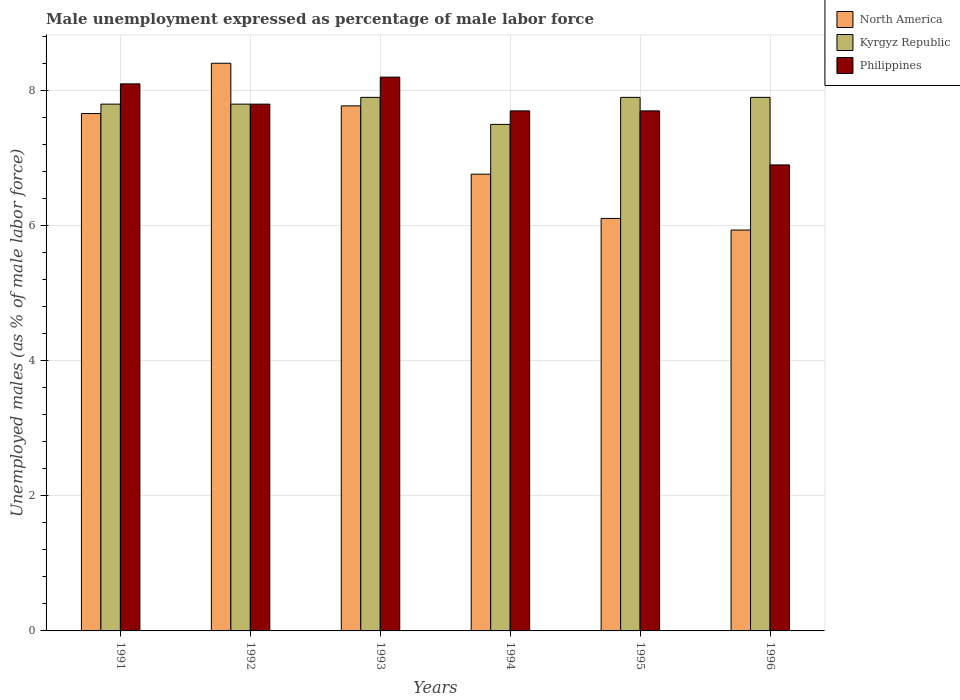Are the number of bars per tick equal to the number of legend labels?
Keep it short and to the point. Yes. How many bars are there on the 6th tick from the left?
Offer a terse response. 3. In how many cases, is the number of bars for a given year not equal to the number of legend labels?
Ensure brevity in your answer.  0. What is the unemployment in males in in Kyrgyz Republic in 1994?
Provide a short and direct response. 7.5. Across all years, what is the maximum unemployment in males in in Philippines?
Provide a succinct answer. 8.2. Across all years, what is the minimum unemployment in males in in Philippines?
Provide a short and direct response. 6.9. In which year was the unemployment in males in in Philippines maximum?
Your response must be concise. 1993. What is the total unemployment in males in in Kyrgyz Republic in the graph?
Provide a succinct answer. 46.8. What is the difference between the unemployment in males in in Philippines in 1993 and that in 1996?
Your answer should be very brief. 1.3. What is the difference between the unemployment in males in in Philippines in 1996 and the unemployment in males in in North America in 1995?
Ensure brevity in your answer.  0.79. What is the average unemployment in males in in Philippines per year?
Your answer should be very brief. 7.73. In the year 1996, what is the difference between the unemployment in males in in Kyrgyz Republic and unemployment in males in in North America?
Provide a short and direct response. 1.96. In how many years, is the unemployment in males in in North America greater than 2 %?
Your answer should be compact. 6. What is the ratio of the unemployment in males in in North America in 1995 to that in 1996?
Provide a succinct answer. 1.03. Is the unemployment in males in in North America in 1995 less than that in 1996?
Your response must be concise. No. Is the difference between the unemployment in males in in Kyrgyz Republic in 1995 and 1996 greater than the difference between the unemployment in males in in North America in 1995 and 1996?
Your response must be concise. No. What is the difference between the highest and the second highest unemployment in males in in Philippines?
Offer a very short reply. 0.1. What is the difference between the highest and the lowest unemployment in males in in Philippines?
Ensure brevity in your answer.  1.3. In how many years, is the unemployment in males in in Philippines greater than the average unemployment in males in in Philippines taken over all years?
Offer a very short reply. 3. Is the sum of the unemployment in males in in Kyrgyz Republic in 1991 and 1995 greater than the maximum unemployment in males in in North America across all years?
Make the answer very short. Yes. What does the 2nd bar from the left in 1993 represents?
Keep it short and to the point. Kyrgyz Republic. What does the 2nd bar from the right in 1995 represents?
Offer a terse response. Kyrgyz Republic. How many years are there in the graph?
Make the answer very short. 6. What is the difference between two consecutive major ticks on the Y-axis?
Offer a terse response. 2. Are the values on the major ticks of Y-axis written in scientific E-notation?
Your answer should be compact. No. Does the graph contain any zero values?
Give a very brief answer. No. Does the graph contain grids?
Offer a terse response. Yes. Where does the legend appear in the graph?
Your answer should be very brief. Top right. What is the title of the graph?
Offer a very short reply. Male unemployment expressed as percentage of male labor force. What is the label or title of the Y-axis?
Your response must be concise. Unemployed males (as % of male labor force). What is the Unemployed males (as % of male labor force) in North America in 1991?
Make the answer very short. 7.66. What is the Unemployed males (as % of male labor force) of Kyrgyz Republic in 1991?
Keep it short and to the point. 7.8. What is the Unemployed males (as % of male labor force) in Philippines in 1991?
Ensure brevity in your answer.  8.1. What is the Unemployed males (as % of male labor force) of North America in 1992?
Keep it short and to the point. 8.41. What is the Unemployed males (as % of male labor force) of Kyrgyz Republic in 1992?
Make the answer very short. 7.8. What is the Unemployed males (as % of male labor force) in Philippines in 1992?
Keep it short and to the point. 7.8. What is the Unemployed males (as % of male labor force) of North America in 1993?
Keep it short and to the point. 7.77. What is the Unemployed males (as % of male labor force) in Kyrgyz Republic in 1993?
Keep it short and to the point. 7.9. What is the Unemployed males (as % of male labor force) in Philippines in 1993?
Ensure brevity in your answer.  8.2. What is the Unemployed males (as % of male labor force) of North America in 1994?
Keep it short and to the point. 6.76. What is the Unemployed males (as % of male labor force) in Philippines in 1994?
Ensure brevity in your answer.  7.7. What is the Unemployed males (as % of male labor force) of North America in 1995?
Make the answer very short. 6.11. What is the Unemployed males (as % of male labor force) in Kyrgyz Republic in 1995?
Provide a succinct answer. 7.9. What is the Unemployed males (as % of male labor force) of Philippines in 1995?
Provide a short and direct response. 7.7. What is the Unemployed males (as % of male labor force) of North America in 1996?
Give a very brief answer. 5.94. What is the Unemployed males (as % of male labor force) of Kyrgyz Republic in 1996?
Provide a short and direct response. 7.9. What is the Unemployed males (as % of male labor force) of Philippines in 1996?
Your answer should be compact. 6.9. Across all years, what is the maximum Unemployed males (as % of male labor force) of North America?
Offer a terse response. 8.41. Across all years, what is the maximum Unemployed males (as % of male labor force) in Kyrgyz Republic?
Ensure brevity in your answer.  7.9. Across all years, what is the maximum Unemployed males (as % of male labor force) in Philippines?
Provide a succinct answer. 8.2. Across all years, what is the minimum Unemployed males (as % of male labor force) of North America?
Provide a short and direct response. 5.94. Across all years, what is the minimum Unemployed males (as % of male labor force) in Kyrgyz Republic?
Keep it short and to the point. 7.5. Across all years, what is the minimum Unemployed males (as % of male labor force) of Philippines?
Your answer should be very brief. 6.9. What is the total Unemployed males (as % of male labor force) of North America in the graph?
Provide a short and direct response. 42.65. What is the total Unemployed males (as % of male labor force) of Kyrgyz Republic in the graph?
Make the answer very short. 46.8. What is the total Unemployed males (as % of male labor force) in Philippines in the graph?
Keep it short and to the point. 46.4. What is the difference between the Unemployed males (as % of male labor force) of North America in 1991 and that in 1992?
Provide a short and direct response. -0.74. What is the difference between the Unemployed males (as % of male labor force) in Kyrgyz Republic in 1991 and that in 1992?
Your response must be concise. 0. What is the difference between the Unemployed males (as % of male labor force) in North America in 1991 and that in 1993?
Keep it short and to the point. -0.11. What is the difference between the Unemployed males (as % of male labor force) in North America in 1991 and that in 1994?
Provide a short and direct response. 0.9. What is the difference between the Unemployed males (as % of male labor force) of North America in 1991 and that in 1995?
Your answer should be very brief. 1.55. What is the difference between the Unemployed males (as % of male labor force) in Philippines in 1991 and that in 1995?
Your answer should be very brief. 0.4. What is the difference between the Unemployed males (as % of male labor force) of North America in 1991 and that in 1996?
Offer a very short reply. 1.72. What is the difference between the Unemployed males (as % of male labor force) in Kyrgyz Republic in 1991 and that in 1996?
Your answer should be compact. -0.1. What is the difference between the Unemployed males (as % of male labor force) in Philippines in 1991 and that in 1996?
Offer a very short reply. 1.2. What is the difference between the Unemployed males (as % of male labor force) of North America in 1992 and that in 1993?
Provide a short and direct response. 0.63. What is the difference between the Unemployed males (as % of male labor force) of Philippines in 1992 and that in 1993?
Ensure brevity in your answer.  -0.4. What is the difference between the Unemployed males (as % of male labor force) in North America in 1992 and that in 1994?
Your answer should be very brief. 1.64. What is the difference between the Unemployed males (as % of male labor force) in North America in 1992 and that in 1995?
Ensure brevity in your answer.  2.3. What is the difference between the Unemployed males (as % of male labor force) of North America in 1992 and that in 1996?
Your answer should be very brief. 2.47. What is the difference between the Unemployed males (as % of male labor force) of Kyrgyz Republic in 1992 and that in 1996?
Make the answer very short. -0.1. What is the difference between the Unemployed males (as % of male labor force) in Philippines in 1992 and that in 1996?
Your answer should be very brief. 0.9. What is the difference between the Unemployed males (as % of male labor force) in North America in 1993 and that in 1994?
Offer a terse response. 1.01. What is the difference between the Unemployed males (as % of male labor force) of North America in 1993 and that in 1995?
Offer a terse response. 1.67. What is the difference between the Unemployed males (as % of male labor force) in Philippines in 1993 and that in 1995?
Ensure brevity in your answer.  0.5. What is the difference between the Unemployed males (as % of male labor force) of North America in 1993 and that in 1996?
Your response must be concise. 1.84. What is the difference between the Unemployed males (as % of male labor force) of Kyrgyz Republic in 1993 and that in 1996?
Your answer should be very brief. 0. What is the difference between the Unemployed males (as % of male labor force) in North America in 1994 and that in 1995?
Offer a terse response. 0.66. What is the difference between the Unemployed males (as % of male labor force) of Kyrgyz Republic in 1994 and that in 1995?
Your answer should be very brief. -0.4. What is the difference between the Unemployed males (as % of male labor force) of North America in 1994 and that in 1996?
Give a very brief answer. 0.83. What is the difference between the Unemployed males (as % of male labor force) in Kyrgyz Republic in 1994 and that in 1996?
Provide a short and direct response. -0.4. What is the difference between the Unemployed males (as % of male labor force) in Philippines in 1994 and that in 1996?
Ensure brevity in your answer.  0.8. What is the difference between the Unemployed males (as % of male labor force) in North America in 1995 and that in 1996?
Ensure brevity in your answer.  0.17. What is the difference between the Unemployed males (as % of male labor force) of North America in 1991 and the Unemployed males (as % of male labor force) of Kyrgyz Republic in 1992?
Your response must be concise. -0.14. What is the difference between the Unemployed males (as % of male labor force) of North America in 1991 and the Unemployed males (as % of male labor force) of Philippines in 1992?
Provide a short and direct response. -0.14. What is the difference between the Unemployed males (as % of male labor force) of North America in 1991 and the Unemployed males (as % of male labor force) of Kyrgyz Republic in 1993?
Provide a short and direct response. -0.24. What is the difference between the Unemployed males (as % of male labor force) in North America in 1991 and the Unemployed males (as % of male labor force) in Philippines in 1993?
Your answer should be compact. -0.54. What is the difference between the Unemployed males (as % of male labor force) of North America in 1991 and the Unemployed males (as % of male labor force) of Kyrgyz Republic in 1994?
Your answer should be compact. 0.16. What is the difference between the Unemployed males (as % of male labor force) in North America in 1991 and the Unemployed males (as % of male labor force) in Philippines in 1994?
Offer a very short reply. -0.04. What is the difference between the Unemployed males (as % of male labor force) in North America in 1991 and the Unemployed males (as % of male labor force) in Kyrgyz Republic in 1995?
Ensure brevity in your answer.  -0.24. What is the difference between the Unemployed males (as % of male labor force) in North America in 1991 and the Unemployed males (as % of male labor force) in Philippines in 1995?
Give a very brief answer. -0.04. What is the difference between the Unemployed males (as % of male labor force) of North America in 1991 and the Unemployed males (as % of male labor force) of Kyrgyz Republic in 1996?
Offer a very short reply. -0.24. What is the difference between the Unemployed males (as % of male labor force) in North America in 1991 and the Unemployed males (as % of male labor force) in Philippines in 1996?
Provide a short and direct response. 0.76. What is the difference between the Unemployed males (as % of male labor force) in North America in 1992 and the Unemployed males (as % of male labor force) in Kyrgyz Republic in 1993?
Provide a short and direct response. 0.51. What is the difference between the Unemployed males (as % of male labor force) of North America in 1992 and the Unemployed males (as % of male labor force) of Philippines in 1993?
Keep it short and to the point. 0.21. What is the difference between the Unemployed males (as % of male labor force) in Kyrgyz Republic in 1992 and the Unemployed males (as % of male labor force) in Philippines in 1993?
Make the answer very short. -0.4. What is the difference between the Unemployed males (as % of male labor force) of North America in 1992 and the Unemployed males (as % of male labor force) of Kyrgyz Republic in 1994?
Your answer should be very brief. 0.91. What is the difference between the Unemployed males (as % of male labor force) in North America in 1992 and the Unemployed males (as % of male labor force) in Philippines in 1994?
Provide a short and direct response. 0.71. What is the difference between the Unemployed males (as % of male labor force) of North America in 1992 and the Unemployed males (as % of male labor force) of Kyrgyz Republic in 1995?
Your answer should be compact. 0.51. What is the difference between the Unemployed males (as % of male labor force) in North America in 1992 and the Unemployed males (as % of male labor force) in Philippines in 1995?
Your answer should be compact. 0.71. What is the difference between the Unemployed males (as % of male labor force) in Kyrgyz Republic in 1992 and the Unemployed males (as % of male labor force) in Philippines in 1995?
Your answer should be very brief. 0.1. What is the difference between the Unemployed males (as % of male labor force) in North America in 1992 and the Unemployed males (as % of male labor force) in Kyrgyz Republic in 1996?
Your answer should be compact. 0.51. What is the difference between the Unemployed males (as % of male labor force) in North America in 1992 and the Unemployed males (as % of male labor force) in Philippines in 1996?
Your response must be concise. 1.51. What is the difference between the Unemployed males (as % of male labor force) of North America in 1993 and the Unemployed males (as % of male labor force) of Kyrgyz Republic in 1994?
Your answer should be very brief. 0.27. What is the difference between the Unemployed males (as % of male labor force) of North America in 1993 and the Unemployed males (as % of male labor force) of Philippines in 1994?
Your answer should be very brief. 0.07. What is the difference between the Unemployed males (as % of male labor force) in Kyrgyz Republic in 1993 and the Unemployed males (as % of male labor force) in Philippines in 1994?
Provide a short and direct response. 0.2. What is the difference between the Unemployed males (as % of male labor force) in North America in 1993 and the Unemployed males (as % of male labor force) in Kyrgyz Republic in 1995?
Your answer should be very brief. -0.13. What is the difference between the Unemployed males (as % of male labor force) in North America in 1993 and the Unemployed males (as % of male labor force) in Philippines in 1995?
Give a very brief answer. 0.07. What is the difference between the Unemployed males (as % of male labor force) in Kyrgyz Republic in 1993 and the Unemployed males (as % of male labor force) in Philippines in 1995?
Ensure brevity in your answer.  0.2. What is the difference between the Unemployed males (as % of male labor force) of North America in 1993 and the Unemployed males (as % of male labor force) of Kyrgyz Republic in 1996?
Your answer should be compact. -0.13. What is the difference between the Unemployed males (as % of male labor force) in North America in 1993 and the Unemployed males (as % of male labor force) in Philippines in 1996?
Your answer should be very brief. 0.87. What is the difference between the Unemployed males (as % of male labor force) in North America in 1994 and the Unemployed males (as % of male labor force) in Kyrgyz Republic in 1995?
Offer a very short reply. -1.14. What is the difference between the Unemployed males (as % of male labor force) in North America in 1994 and the Unemployed males (as % of male labor force) in Philippines in 1995?
Your answer should be compact. -0.94. What is the difference between the Unemployed males (as % of male labor force) in Kyrgyz Republic in 1994 and the Unemployed males (as % of male labor force) in Philippines in 1995?
Your response must be concise. -0.2. What is the difference between the Unemployed males (as % of male labor force) in North America in 1994 and the Unemployed males (as % of male labor force) in Kyrgyz Republic in 1996?
Your response must be concise. -1.14. What is the difference between the Unemployed males (as % of male labor force) in North America in 1994 and the Unemployed males (as % of male labor force) in Philippines in 1996?
Provide a short and direct response. -0.14. What is the difference between the Unemployed males (as % of male labor force) in North America in 1995 and the Unemployed males (as % of male labor force) in Kyrgyz Republic in 1996?
Make the answer very short. -1.79. What is the difference between the Unemployed males (as % of male labor force) of North America in 1995 and the Unemployed males (as % of male labor force) of Philippines in 1996?
Give a very brief answer. -0.79. What is the difference between the Unemployed males (as % of male labor force) of Kyrgyz Republic in 1995 and the Unemployed males (as % of male labor force) of Philippines in 1996?
Provide a succinct answer. 1. What is the average Unemployed males (as % of male labor force) in North America per year?
Offer a terse response. 7.11. What is the average Unemployed males (as % of male labor force) in Philippines per year?
Make the answer very short. 7.73. In the year 1991, what is the difference between the Unemployed males (as % of male labor force) of North America and Unemployed males (as % of male labor force) of Kyrgyz Republic?
Offer a terse response. -0.14. In the year 1991, what is the difference between the Unemployed males (as % of male labor force) of North America and Unemployed males (as % of male labor force) of Philippines?
Ensure brevity in your answer.  -0.44. In the year 1991, what is the difference between the Unemployed males (as % of male labor force) of Kyrgyz Republic and Unemployed males (as % of male labor force) of Philippines?
Provide a short and direct response. -0.3. In the year 1992, what is the difference between the Unemployed males (as % of male labor force) of North America and Unemployed males (as % of male labor force) of Kyrgyz Republic?
Offer a very short reply. 0.61. In the year 1992, what is the difference between the Unemployed males (as % of male labor force) in North America and Unemployed males (as % of male labor force) in Philippines?
Give a very brief answer. 0.61. In the year 1992, what is the difference between the Unemployed males (as % of male labor force) in Kyrgyz Republic and Unemployed males (as % of male labor force) in Philippines?
Your response must be concise. 0. In the year 1993, what is the difference between the Unemployed males (as % of male labor force) in North America and Unemployed males (as % of male labor force) in Kyrgyz Republic?
Keep it short and to the point. -0.13. In the year 1993, what is the difference between the Unemployed males (as % of male labor force) in North America and Unemployed males (as % of male labor force) in Philippines?
Give a very brief answer. -0.43. In the year 1994, what is the difference between the Unemployed males (as % of male labor force) in North America and Unemployed males (as % of male labor force) in Kyrgyz Republic?
Provide a succinct answer. -0.74. In the year 1994, what is the difference between the Unemployed males (as % of male labor force) in North America and Unemployed males (as % of male labor force) in Philippines?
Make the answer very short. -0.94. In the year 1995, what is the difference between the Unemployed males (as % of male labor force) of North America and Unemployed males (as % of male labor force) of Kyrgyz Republic?
Your answer should be very brief. -1.79. In the year 1995, what is the difference between the Unemployed males (as % of male labor force) of North America and Unemployed males (as % of male labor force) of Philippines?
Offer a very short reply. -1.59. In the year 1996, what is the difference between the Unemployed males (as % of male labor force) of North America and Unemployed males (as % of male labor force) of Kyrgyz Republic?
Provide a succinct answer. -1.96. In the year 1996, what is the difference between the Unemployed males (as % of male labor force) in North America and Unemployed males (as % of male labor force) in Philippines?
Provide a succinct answer. -0.96. In the year 1996, what is the difference between the Unemployed males (as % of male labor force) in Kyrgyz Republic and Unemployed males (as % of male labor force) in Philippines?
Offer a very short reply. 1. What is the ratio of the Unemployed males (as % of male labor force) in North America in 1991 to that in 1992?
Your response must be concise. 0.91. What is the ratio of the Unemployed males (as % of male labor force) of Philippines in 1991 to that in 1992?
Offer a very short reply. 1.04. What is the ratio of the Unemployed males (as % of male labor force) in North America in 1991 to that in 1993?
Ensure brevity in your answer.  0.99. What is the ratio of the Unemployed males (as % of male labor force) in Kyrgyz Republic in 1991 to that in 1993?
Your answer should be compact. 0.99. What is the ratio of the Unemployed males (as % of male labor force) in Philippines in 1991 to that in 1993?
Your answer should be compact. 0.99. What is the ratio of the Unemployed males (as % of male labor force) in North America in 1991 to that in 1994?
Your answer should be compact. 1.13. What is the ratio of the Unemployed males (as % of male labor force) of Philippines in 1991 to that in 1994?
Ensure brevity in your answer.  1.05. What is the ratio of the Unemployed males (as % of male labor force) of North America in 1991 to that in 1995?
Make the answer very short. 1.25. What is the ratio of the Unemployed males (as % of male labor force) in Kyrgyz Republic in 1991 to that in 1995?
Ensure brevity in your answer.  0.99. What is the ratio of the Unemployed males (as % of male labor force) in Philippines in 1991 to that in 1995?
Provide a succinct answer. 1.05. What is the ratio of the Unemployed males (as % of male labor force) of North America in 1991 to that in 1996?
Provide a short and direct response. 1.29. What is the ratio of the Unemployed males (as % of male labor force) in Kyrgyz Republic in 1991 to that in 1996?
Provide a succinct answer. 0.99. What is the ratio of the Unemployed males (as % of male labor force) in Philippines in 1991 to that in 1996?
Keep it short and to the point. 1.17. What is the ratio of the Unemployed males (as % of male labor force) of North America in 1992 to that in 1993?
Offer a very short reply. 1.08. What is the ratio of the Unemployed males (as % of male labor force) in Kyrgyz Republic in 1992 to that in 1993?
Your response must be concise. 0.99. What is the ratio of the Unemployed males (as % of male labor force) in Philippines in 1992 to that in 1993?
Ensure brevity in your answer.  0.95. What is the ratio of the Unemployed males (as % of male labor force) in North America in 1992 to that in 1994?
Make the answer very short. 1.24. What is the ratio of the Unemployed males (as % of male labor force) in North America in 1992 to that in 1995?
Offer a very short reply. 1.38. What is the ratio of the Unemployed males (as % of male labor force) in Kyrgyz Republic in 1992 to that in 1995?
Provide a short and direct response. 0.99. What is the ratio of the Unemployed males (as % of male labor force) in North America in 1992 to that in 1996?
Your answer should be compact. 1.42. What is the ratio of the Unemployed males (as % of male labor force) of Kyrgyz Republic in 1992 to that in 1996?
Ensure brevity in your answer.  0.99. What is the ratio of the Unemployed males (as % of male labor force) of Philippines in 1992 to that in 1996?
Make the answer very short. 1.13. What is the ratio of the Unemployed males (as % of male labor force) in North America in 1993 to that in 1994?
Provide a succinct answer. 1.15. What is the ratio of the Unemployed males (as % of male labor force) in Kyrgyz Republic in 1993 to that in 1994?
Provide a short and direct response. 1.05. What is the ratio of the Unemployed males (as % of male labor force) of Philippines in 1993 to that in 1994?
Give a very brief answer. 1.06. What is the ratio of the Unemployed males (as % of male labor force) of North America in 1993 to that in 1995?
Your answer should be compact. 1.27. What is the ratio of the Unemployed males (as % of male labor force) of Philippines in 1993 to that in 1995?
Your response must be concise. 1.06. What is the ratio of the Unemployed males (as % of male labor force) of North America in 1993 to that in 1996?
Keep it short and to the point. 1.31. What is the ratio of the Unemployed males (as % of male labor force) in Kyrgyz Republic in 1993 to that in 1996?
Your answer should be very brief. 1. What is the ratio of the Unemployed males (as % of male labor force) of Philippines in 1993 to that in 1996?
Provide a short and direct response. 1.19. What is the ratio of the Unemployed males (as % of male labor force) in North America in 1994 to that in 1995?
Your response must be concise. 1.11. What is the ratio of the Unemployed males (as % of male labor force) in Kyrgyz Republic in 1994 to that in 1995?
Provide a succinct answer. 0.95. What is the ratio of the Unemployed males (as % of male labor force) in North America in 1994 to that in 1996?
Your response must be concise. 1.14. What is the ratio of the Unemployed males (as % of male labor force) in Kyrgyz Republic in 1994 to that in 1996?
Provide a short and direct response. 0.95. What is the ratio of the Unemployed males (as % of male labor force) in Philippines in 1994 to that in 1996?
Your response must be concise. 1.12. What is the ratio of the Unemployed males (as % of male labor force) of North America in 1995 to that in 1996?
Ensure brevity in your answer.  1.03. What is the ratio of the Unemployed males (as % of male labor force) of Philippines in 1995 to that in 1996?
Make the answer very short. 1.12. What is the difference between the highest and the second highest Unemployed males (as % of male labor force) in North America?
Keep it short and to the point. 0.63. What is the difference between the highest and the second highest Unemployed males (as % of male labor force) in Kyrgyz Republic?
Offer a very short reply. 0. What is the difference between the highest and the second highest Unemployed males (as % of male labor force) of Philippines?
Give a very brief answer. 0.1. What is the difference between the highest and the lowest Unemployed males (as % of male labor force) of North America?
Ensure brevity in your answer.  2.47. What is the difference between the highest and the lowest Unemployed males (as % of male labor force) of Kyrgyz Republic?
Provide a short and direct response. 0.4. 